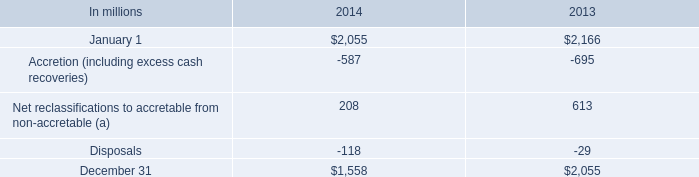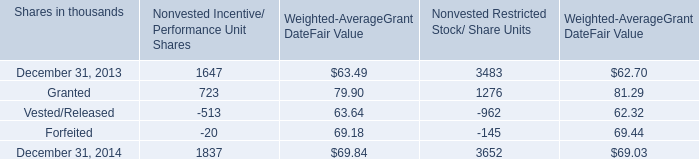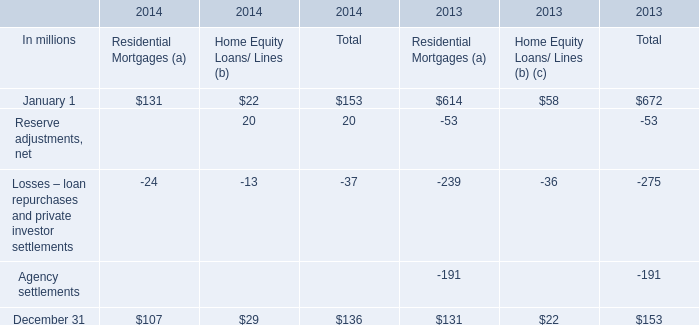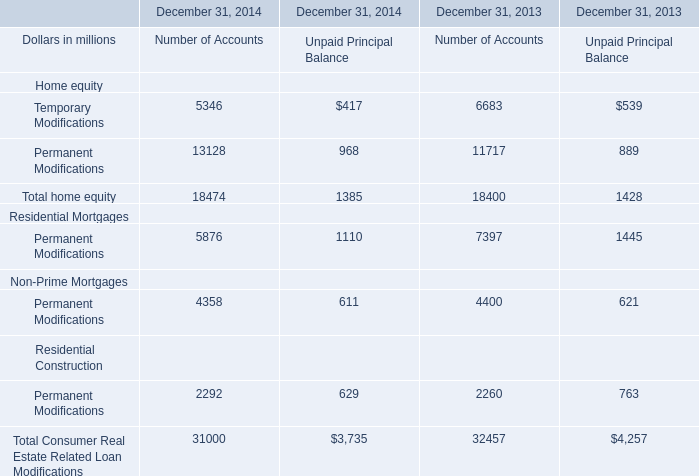What is the average amount of December 31, 2014 of Nonvested Incentive/ Performance Unit Shares, and January 1 of 2013 ? 
Computations: ((1837.0 + 2166.0) / 2)
Answer: 2001.5. What is the sum of January 1 of 2013, and Temporary Modifications of December 31, 2013 Number of Accounts ? 
Computations: (2166.0 + 6683.0)
Answer: 8849.0. what was the approximate average , in millions , for the tax benefit realized from option exercises under all incentive plans for 2014 , 2013 and 2012? 
Computations: (((33 + 31) + 14) / 3)
Answer: 26.0. What is the average amount of Granted of Nonvested Restricted Stock/ Share Units, and January 1 of 2014 ? 
Computations: ((1276.0 + 2055.0) / 2)
Answer: 1665.5. 